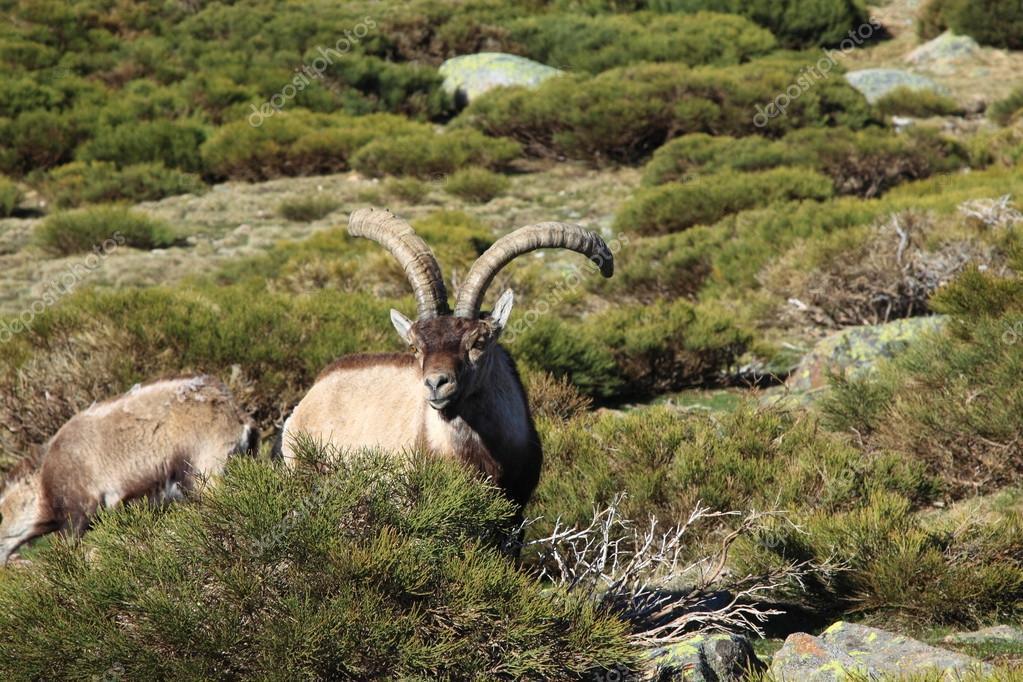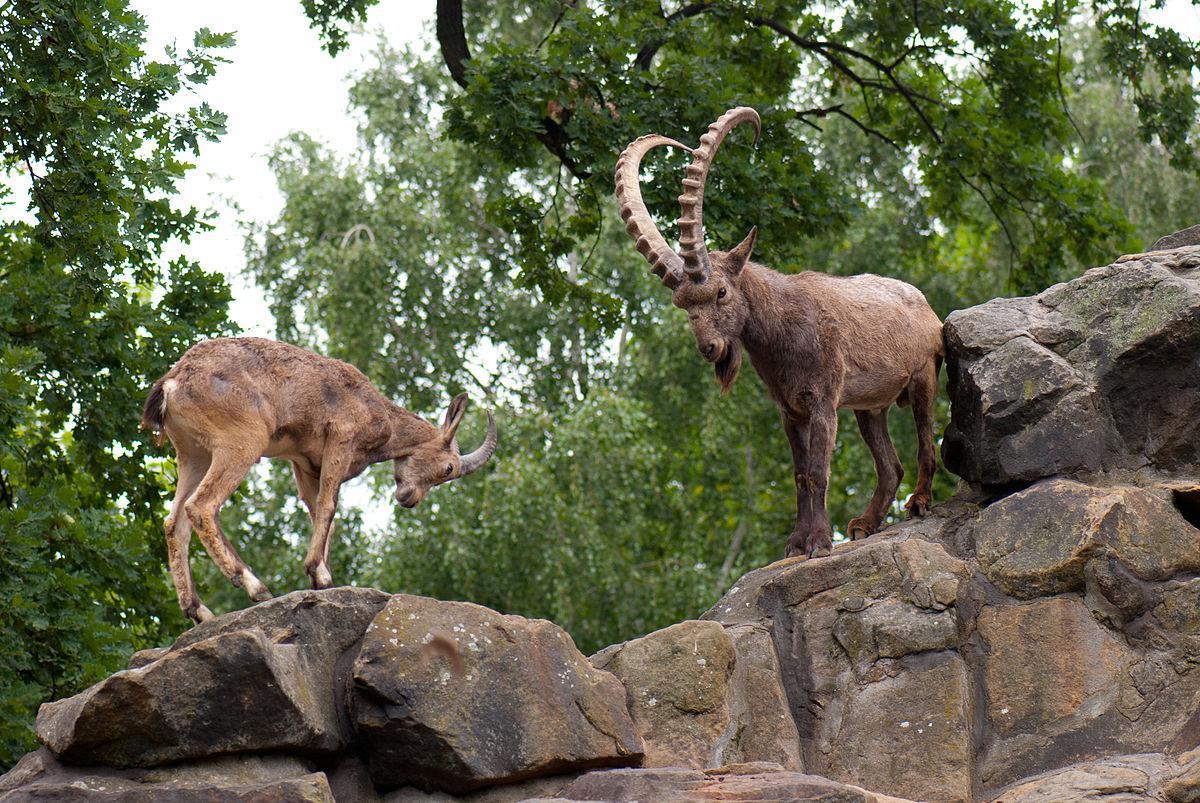The first image is the image on the left, the second image is the image on the right. Given the left and right images, does the statement "An image shows a younger goat standing near an adult goat." hold true? Answer yes or no. Yes. 